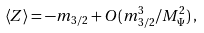<formula> <loc_0><loc_0><loc_500><loc_500>\left \langle Z \right \rangle = - m _ { 3 / 2 } + O ( m _ { 3 / 2 } ^ { 3 } / M _ { \Psi } ^ { 2 } ) \, ,</formula> 